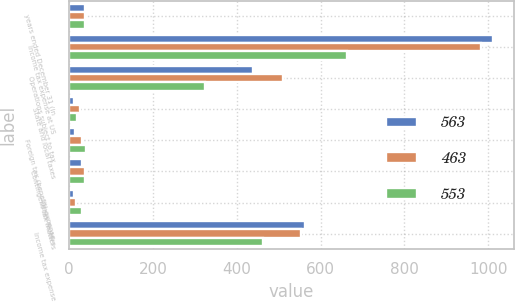Convert chart. <chart><loc_0><loc_0><loc_500><loc_500><stacked_bar_chart><ecel><fcel>years ended December 31 (in<fcel>Income tax expense at US<fcel>Operations subject to tax<fcel>State and local taxes<fcel>Foreign tax (benefit) expense<fcel>Contingent tax matters<fcel>Other factors<fcel>Income tax expense<nl><fcel>563<fcel>39<fcel>1011<fcel>439<fcel>11<fcel>15<fcel>30<fcel>13<fcel>563<nl><fcel>463<fcel>39<fcel>983<fcel>510<fcel>25<fcel>32<fcel>39<fcel>16<fcel>553<nl><fcel>553<fcel>39<fcel>662<fcel>325<fcel>18<fcel>40<fcel>39<fcel>32<fcel>463<nl></chart> 